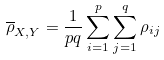Convert formula to latex. <formula><loc_0><loc_0><loc_500><loc_500>\overline { \rho } _ { X , Y } = \frac { 1 } { p q } \sum _ { i = 1 } ^ { p } \sum _ { j = 1 } ^ { q } \rho _ { i j }</formula> 